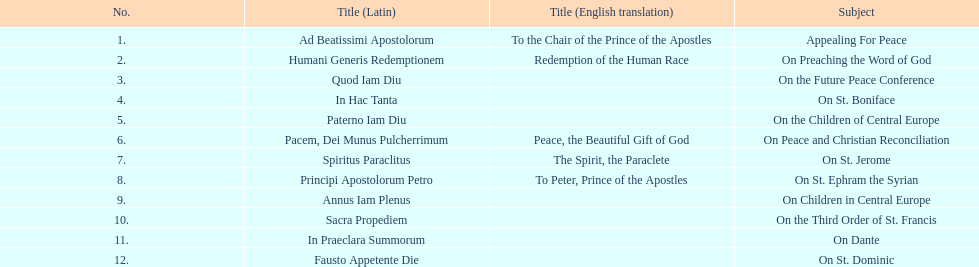Can you parse all the data within this table? {'header': ['No.', 'Title (Latin)', 'Title (English translation)', 'Subject'], 'rows': [['1.', 'Ad Beatissimi Apostolorum', 'To the Chair of the Prince of the Apostles', 'Appealing For Peace'], ['2.', 'Humani Generis Redemptionem', 'Redemption of the Human Race', 'On Preaching the Word of God'], ['3.', 'Quod Iam Diu', '', 'On the Future Peace Conference'], ['4.', 'In Hac Tanta', '', 'On St. Boniface'], ['5.', 'Paterno Iam Diu', '', 'On the Children of Central Europe'], ['6.', 'Pacem, Dei Munus Pulcherrimum', 'Peace, the Beautiful Gift of God', 'On Peace and Christian Reconciliation'], ['7.', 'Spiritus Paraclitus', 'The Spirit, the Paraclete', 'On St. Jerome'], ['8.', 'Principi Apostolorum Petro', 'To Peter, Prince of the Apostles', 'On St. Ephram the Syrian'], ['9.', 'Annus Iam Plenus', '', 'On Children in Central Europe'], ['10.', 'Sacra Propediem', '', 'On the Third Order of St. Francis'], ['11.', 'In Praeclara Summorum', '', 'On Dante'], ['12.', 'Fausto Appetente Die', '', 'On St. Dominic']]} What is the next title listed after sacra propediem? In Praeclara Summorum. 